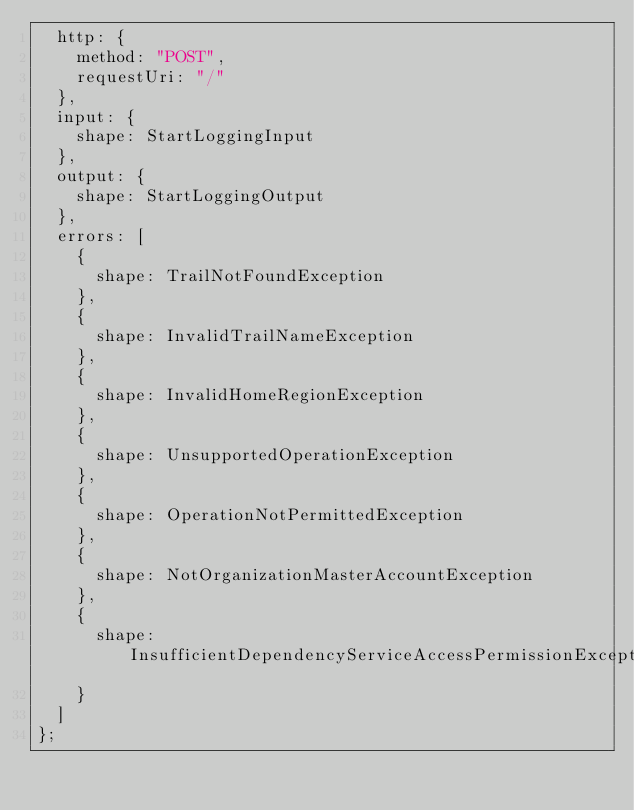<code> <loc_0><loc_0><loc_500><loc_500><_TypeScript_>  http: {
    method: "POST",
    requestUri: "/"
  },
  input: {
    shape: StartLoggingInput
  },
  output: {
    shape: StartLoggingOutput
  },
  errors: [
    {
      shape: TrailNotFoundException
    },
    {
      shape: InvalidTrailNameException
    },
    {
      shape: InvalidHomeRegionException
    },
    {
      shape: UnsupportedOperationException
    },
    {
      shape: OperationNotPermittedException
    },
    {
      shape: NotOrganizationMasterAccountException
    },
    {
      shape: InsufficientDependencyServiceAccessPermissionException
    }
  ]
};
</code> 